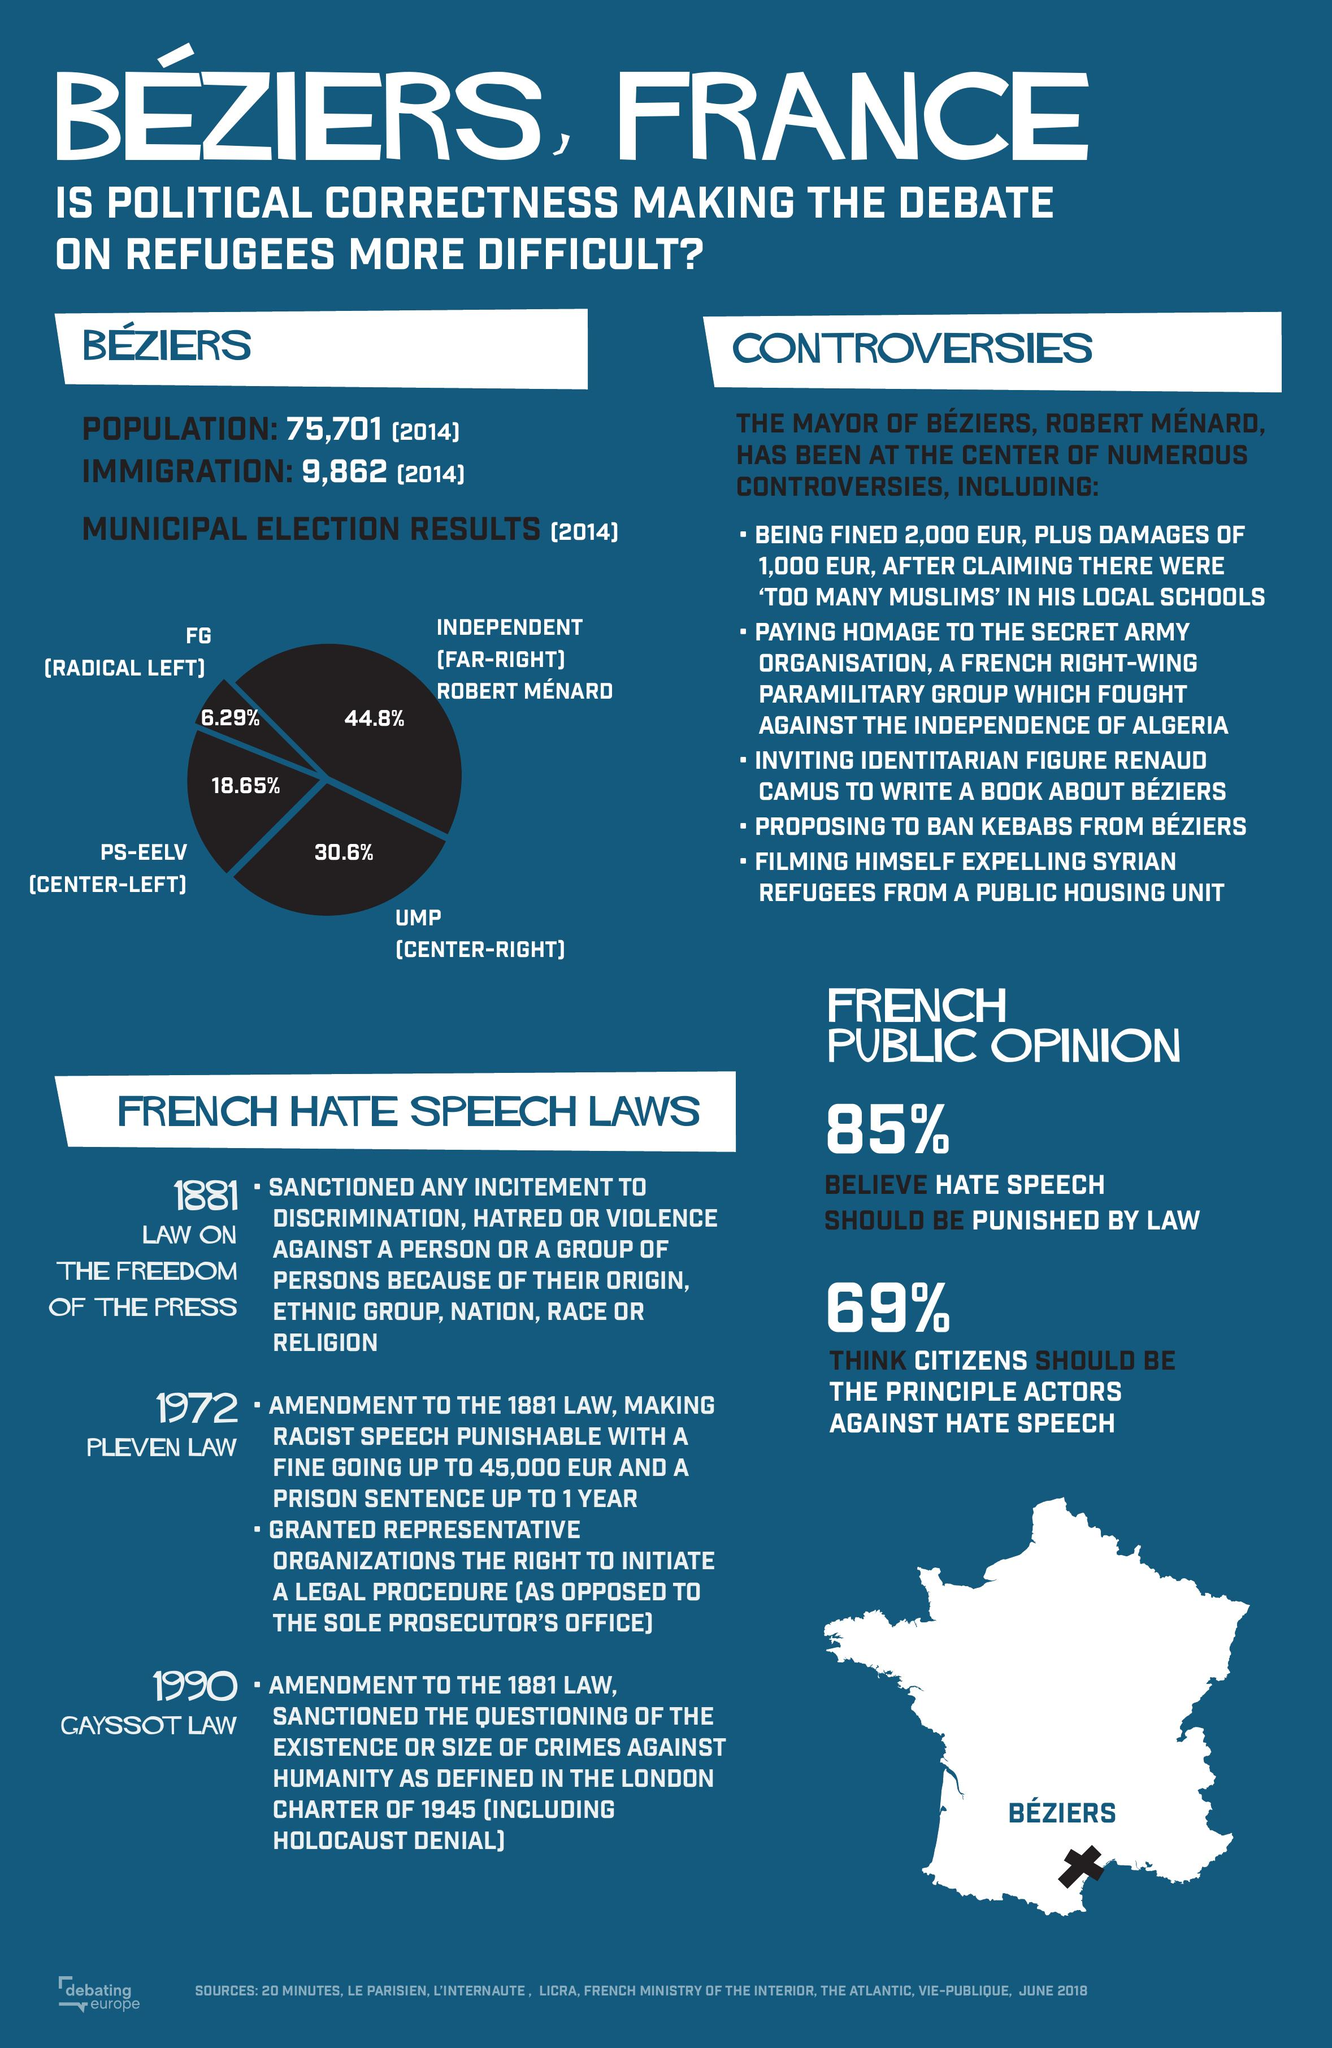Mention a couple of crucial points in this snapshot. The far-right received 44.8% of the votes in a recent election. 